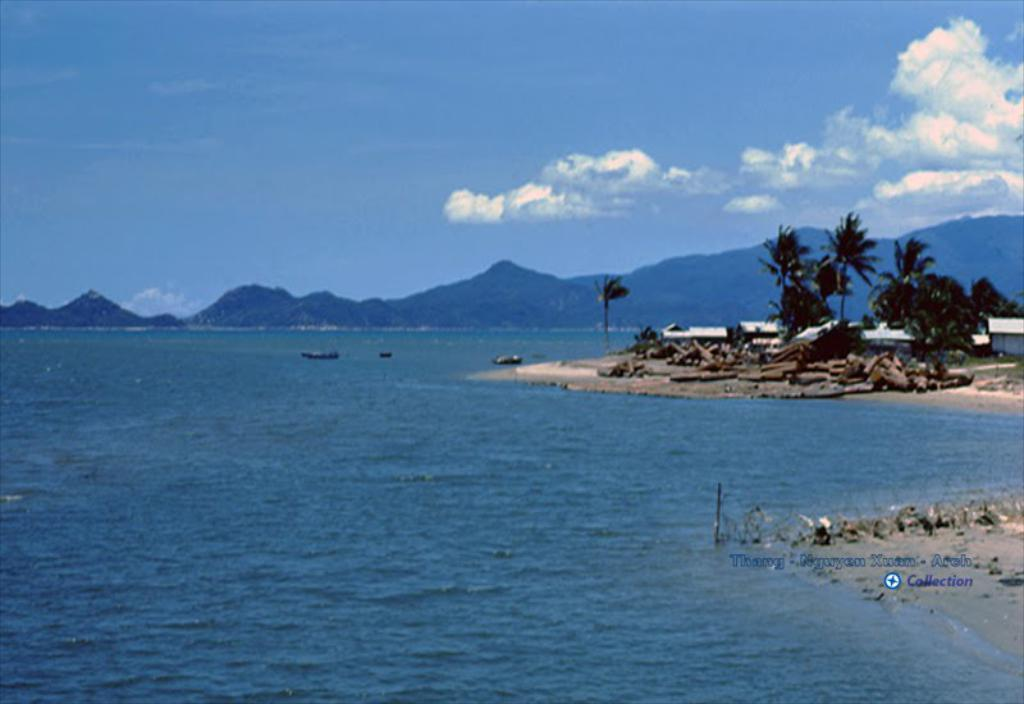What can be seen in the image that is not solid? There is water visible in the image. What type of vegetation is present in the image? There are trees in the image. What type of landscape feature can be seen in the image? There are hills in the image. What is visible above the landscape in the image? The sky is visible in the image. How many bikes are parked near the trees in the image? There are no bikes present in the image. What type of attraction can be seen near the hills in the image? There is no attraction visible in the image; it only features water, trees, hills, and the sky. 